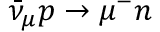<formula> <loc_0><loc_0><loc_500><loc_500>\bar { \nu } _ { \mu } p \to \mu ^ { - } n</formula> 